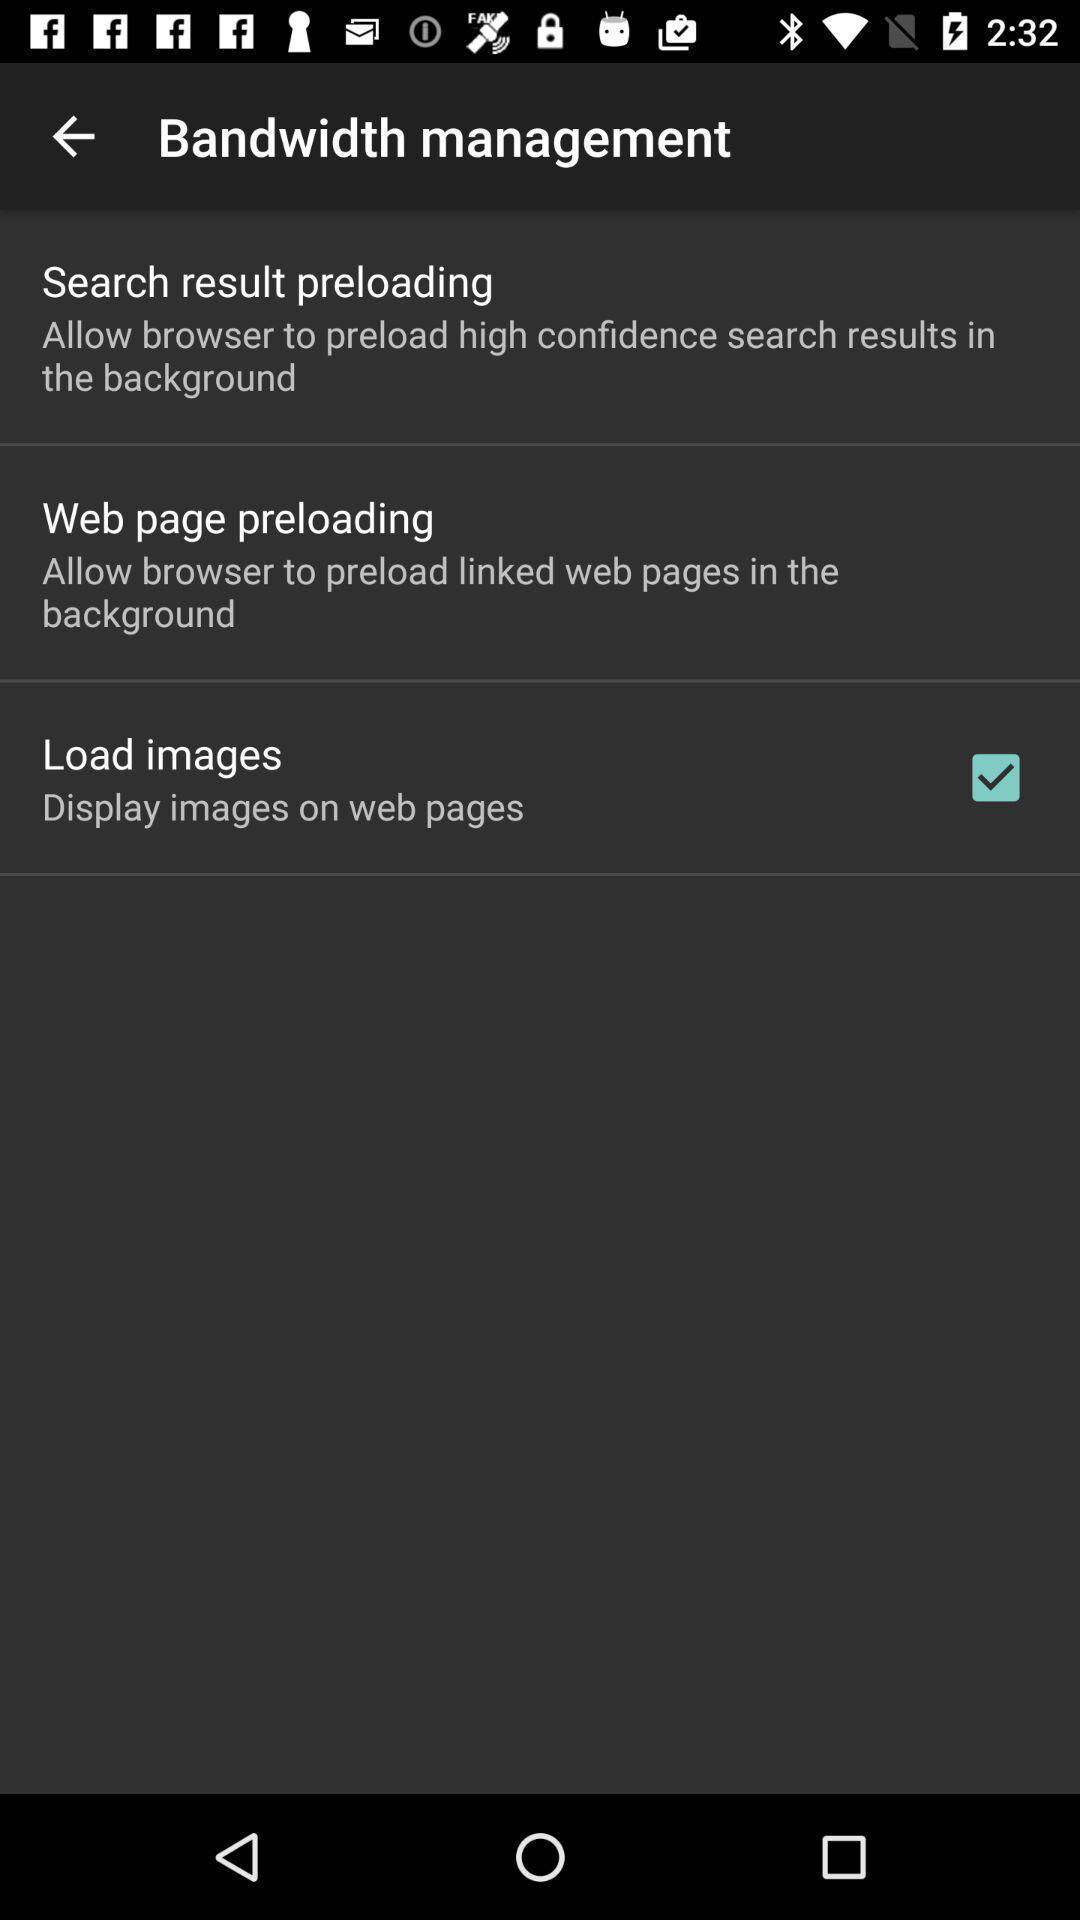Describe the visual elements of this screenshot. Page showing multiple options under bandwidth management. 